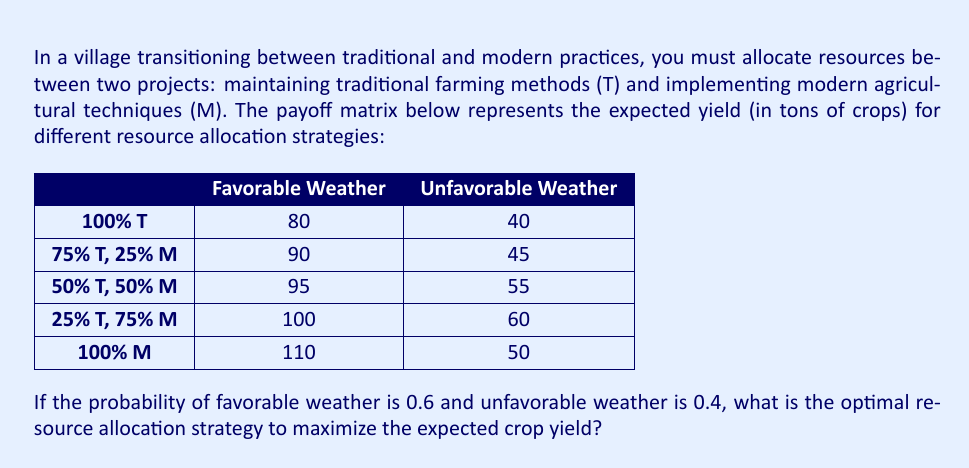Teach me how to tackle this problem. To solve this problem, we'll use the concept of expected value from game theory. We'll calculate the expected yield for each strategy and choose the one with the highest value.

Let's calculate the expected value (EV) for each strategy:

1. 100% Traditional (T):
   $EV = 0.6 \times 80 + 0.4 \times 40 = 48 + 16 = 64$ tons

2. 75% T, 25% M:
   $EV = 0.6 \times 90 + 0.4 \times 45 = 54 + 18 = 72$ tons

3. 50% T, 50% M:
   $EV = 0.6 \times 95 + 0.4 \times 55 = 57 + 22 = 79$ tons

4. 25% T, 75% M:
   $EV = 0.6 \times 100 + 0.4 \times 60 = 60 + 24 = 84$ tons

5. 100% Modern (M):
   $EV = 0.6 \times 110 + 0.4 \times 50 = 66 + 20 = 86$ tons

The strategy with the highest expected yield is 100% Modern (M) with 86 tons.

This result aligns with the persona of a forward-thinking youth eager to embrace modernization, as it shows that fully adopting modern agricultural techniques yields the highest expected crop output.
Answer: The optimal resource allocation strategy is to allocate 100% of resources to modern agricultural techniques (M), which gives an expected crop yield of 86 tons. 